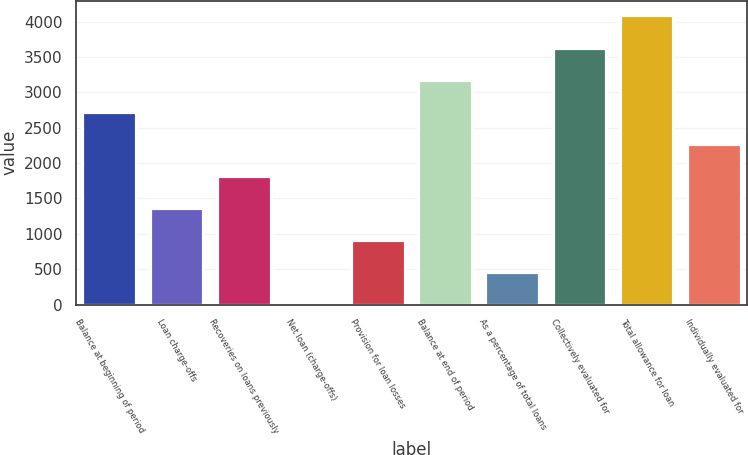Convert chart to OTSL. <chart><loc_0><loc_0><loc_500><loc_500><bar_chart><fcel>Balance at beginning of period<fcel>Loan charge-offs<fcel>Recoveries on loans previously<fcel>Net loan (charge-offs)<fcel>Provision for loan losses<fcel>Balance at end of period<fcel>As a percentage of total loans<fcel>Collectively evaluated for<fcel>Total allowance for loan<fcel>Individually evaluated for<nl><fcel>2725.6<fcel>1363.3<fcel>1817.4<fcel>1<fcel>909.2<fcel>3179.7<fcel>455.1<fcel>3633.8<fcel>4087.9<fcel>2271.5<nl></chart> 